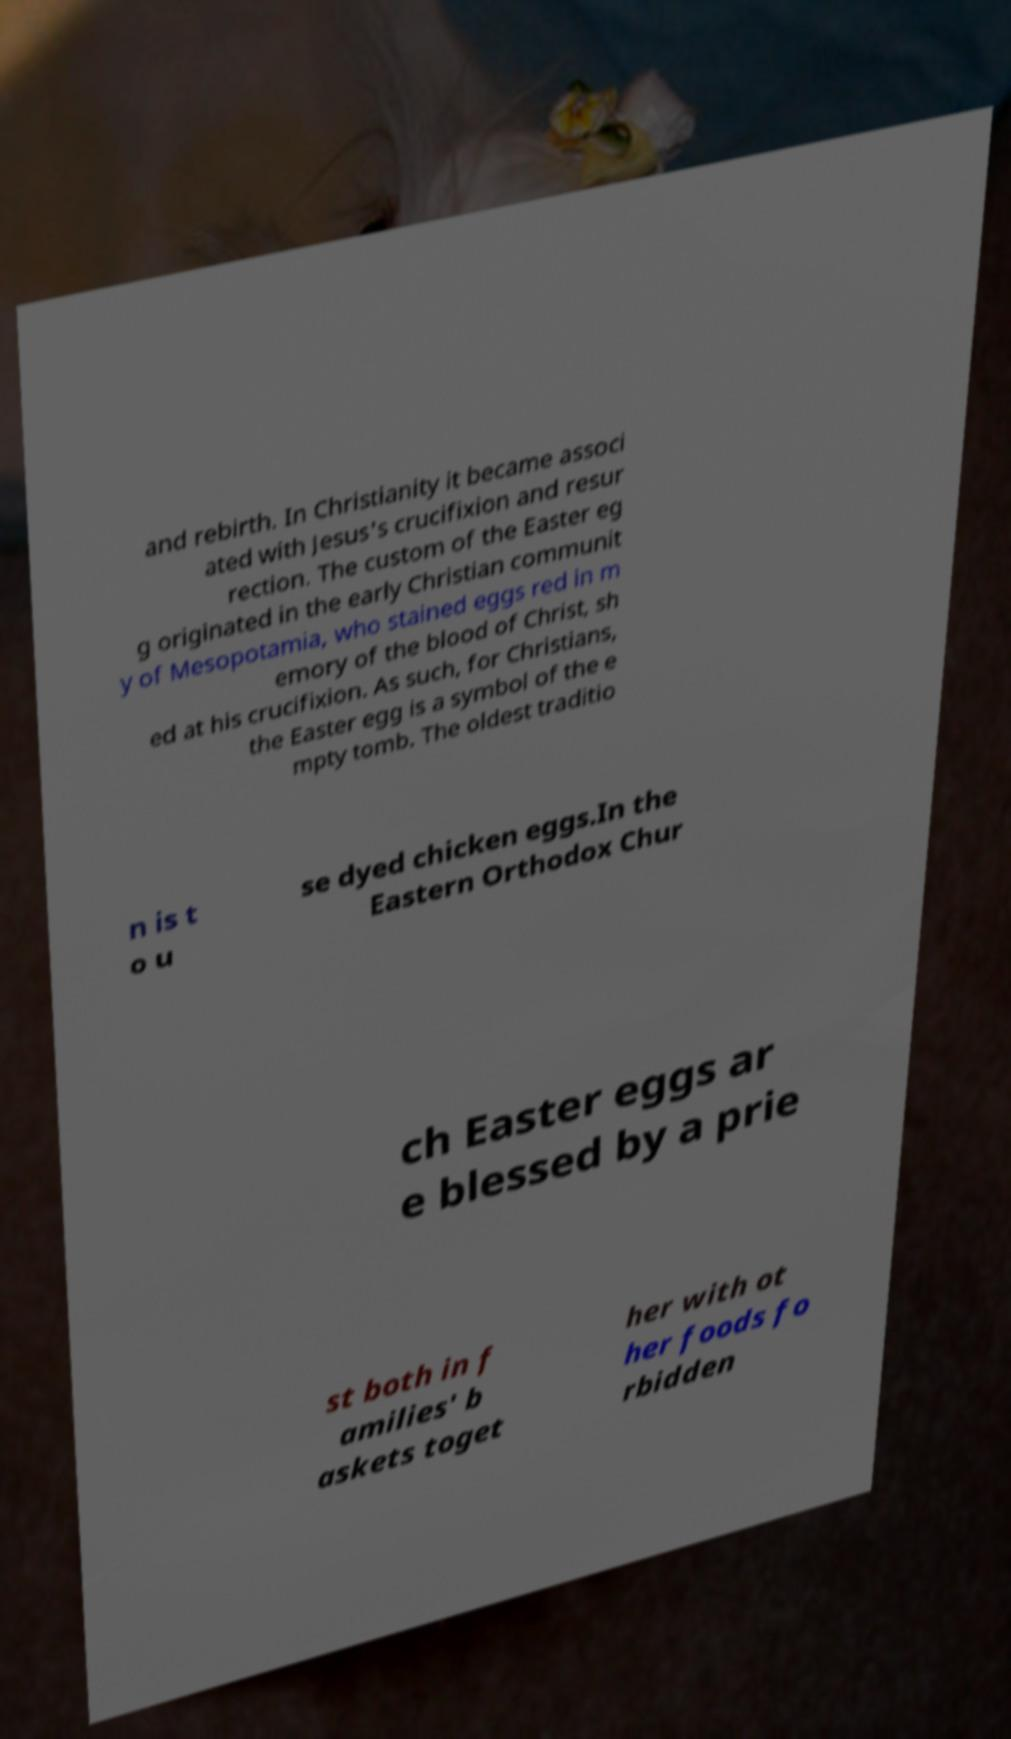For documentation purposes, I need the text within this image transcribed. Could you provide that? and rebirth. In Christianity it became associ ated with Jesus's crucifixion and resur rection. The custom of the Easter eg g originated in the early Christian communit y of Mesopotamia, who stained eggs red in m emory of the blood of Christ, sh ed at his crucifixion. As such, for Christians, the Easter egg is a symbol of the e mpty tomb. The oldest traditio n is t o u se dyed chicken eggs.In the Eastern Orthodox Chur ch Easter eggs ar e blessed by a prie st both in f amilies' b askets toget her with ot her foods fo rbidden 